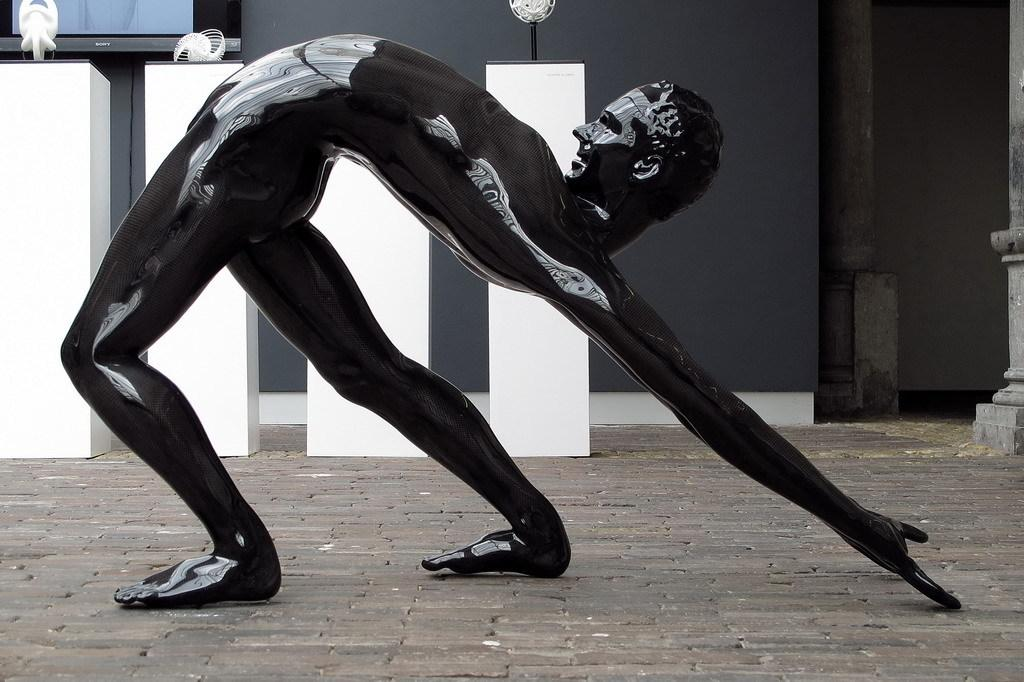What is the main subject in the image? There is a statue in the image. What is located behind the statue? There are tables behind the statue. What is behind the tables? There is a wall behind the tables. What is on the wall? There is a screen on the wall. What page of the book is the oven mentioned on? There is no book or oven present in the image, so this question cannot be answered. 